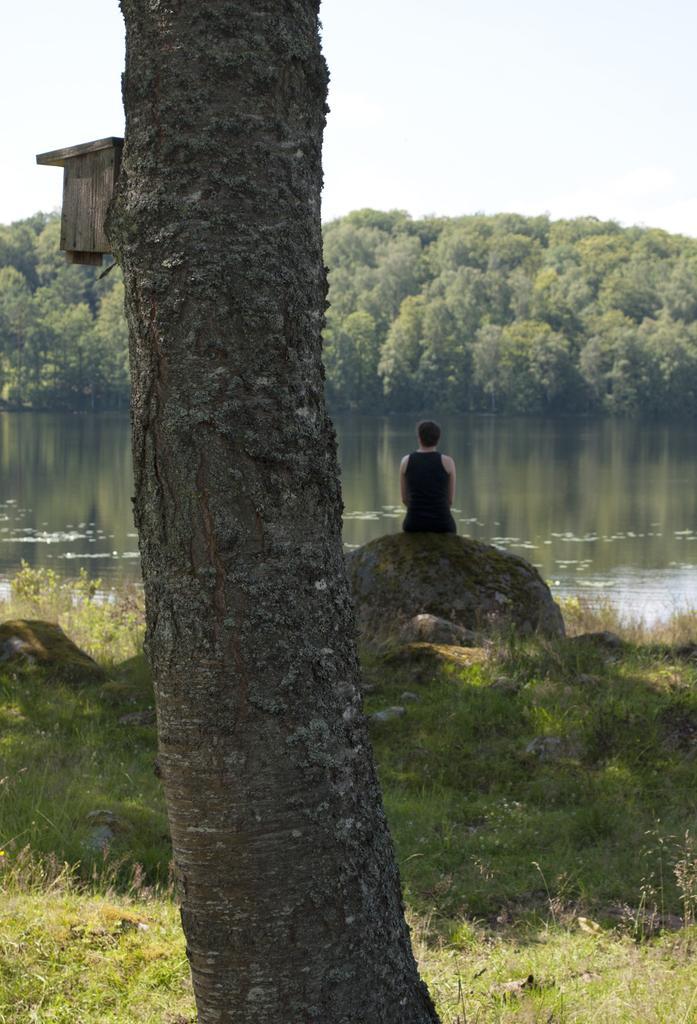Describe this image in one or two sentences. There is a tree trunk. There is grass. A person is sitting on a rock wearing a black dress. There is water and trees at the back and there is sky at the top. 